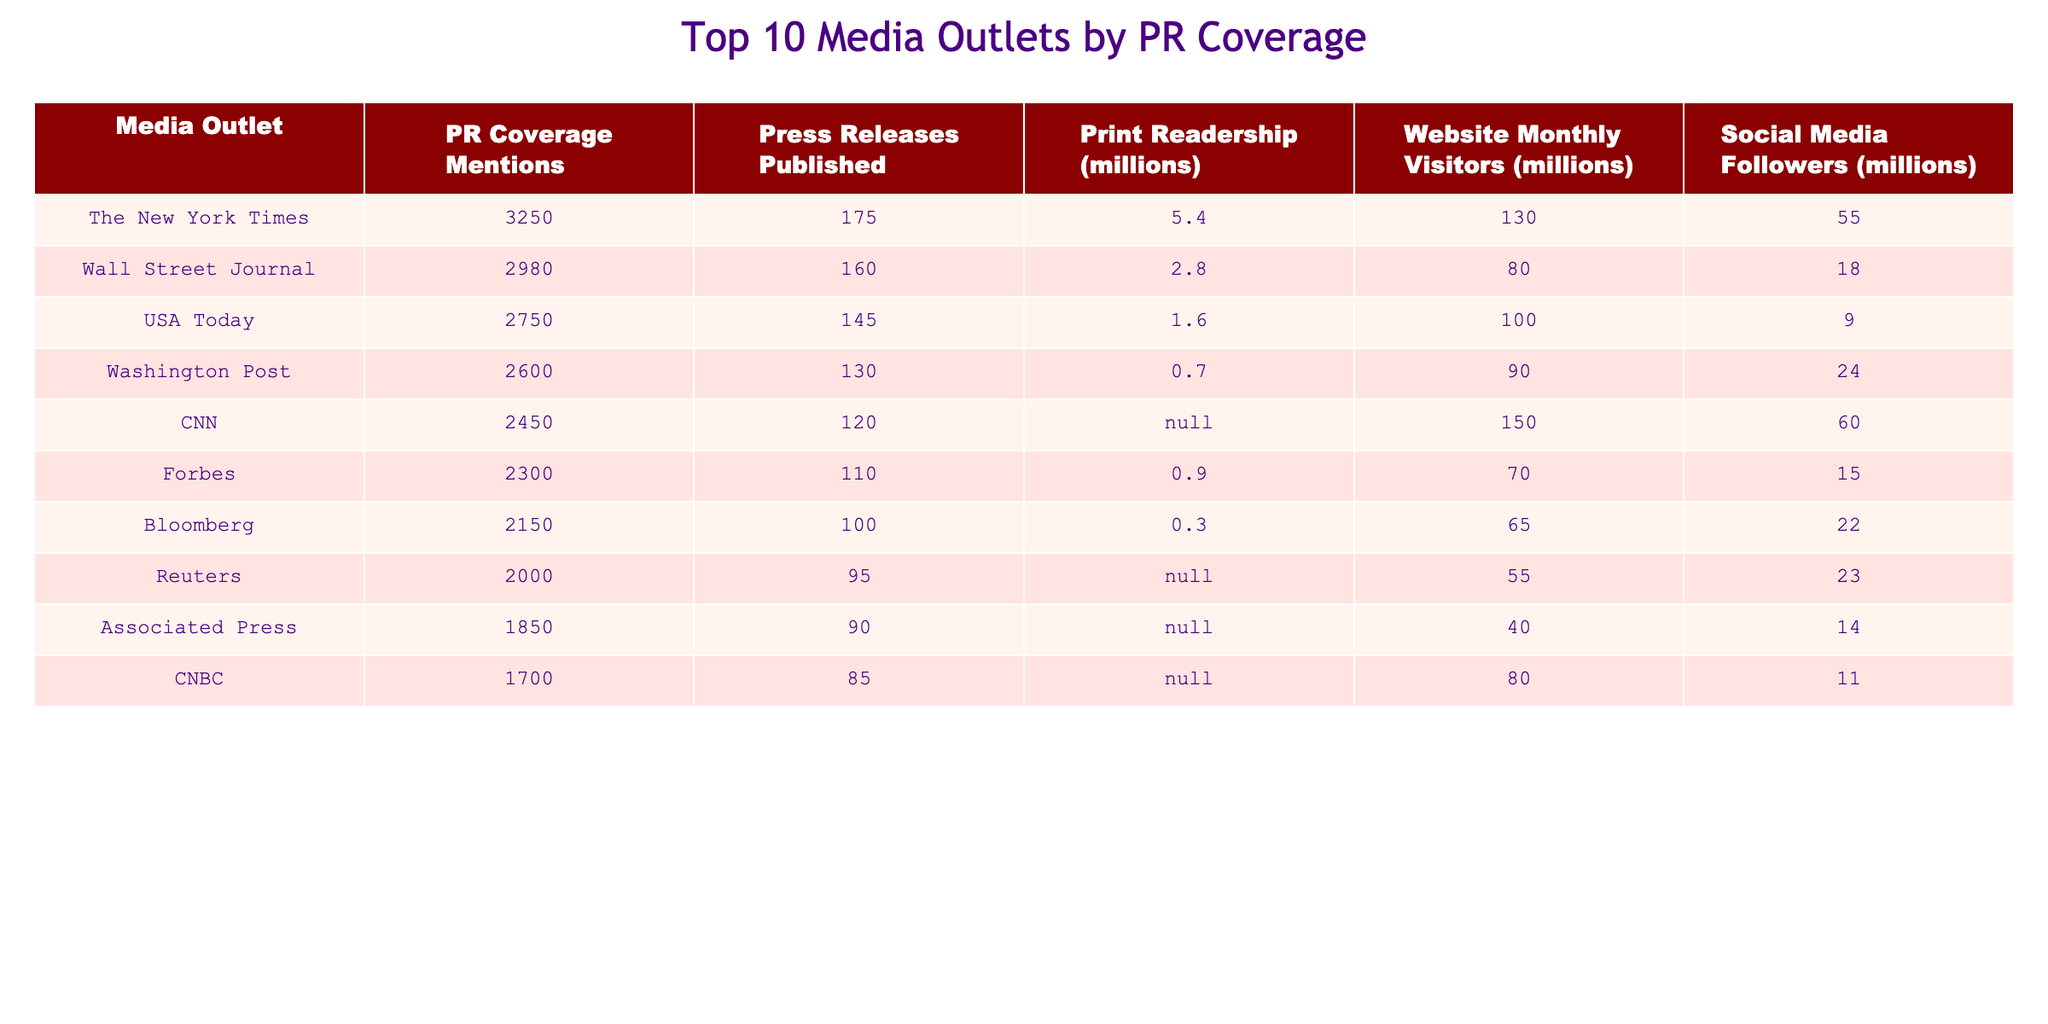What media outlet generated the highest PR coverage mentions in the past year? The table lists the PR coverage mentions for each media outlet. The outlet with the highest mentions is The New York Times at 3250.
Answer: The New York Times How many press releases were published by CNN in the past year? According to the table, CNN published 120 press releases in the past year.
Answer: 120 Which media outlet has the lowest print readership? The Washington Post has the lowest print readership at 0.7 million.
Answer: Washington Post What is the total PR coverage mentions of the top three media outlets? Adding the PR coverage mentions of The New York Times (3250), Wall Street Journal (2980), and USA Today (2750) results in 3250 + 2980 + 2750 = 8980.
Answer: 8980 Which media outlet has more social media followers, Forbes or CNBC? From the table, Forbes has 15 million social media followers while CNBC has 11 million. Therefore, Forbes has more followers.
Answer: Forbes What is the print readership average of the top five media outlets? The print readerships for the top five outlets are: 5.4 (NY Times), 2.8 (WSJ), 1.6 (USA Today), 0.7 (Washington Post), and N/A (CNN). The valid values sum to 10.5 and divide by 4 gives an average of 2.625.
Answer: 2.625 Is Bloomberg's website monthly visitors greater than Associated Press's? Bloomberg has 65 million visitors while Associated Press has 40 million. Therefore, Bloomberg has greater visitors.
Answer: True What are the total social media followers of the top two media outlets? The New York Times has 55 million and Wall Street Journal has 18 million. Adding these gives 55 + 18 = 73 million.
Answer: 73 million How many media outlets have PR coverage mentions greater than 2000? The table shows 6 media outlets—The New York Times, Wall Street Journal, USA Today, Washington Post, CNN, and Forbes—with mentions greater than 2000.
Answer: 6 Which media outlet has the highest print readership, and what is the value? The highest print readership is found in The New York Times, with a readership of 5.4 million.
Answer: The New York Times, 5.4 million 